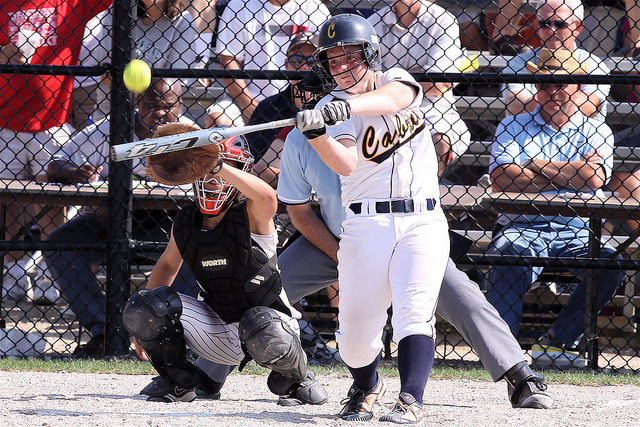How many people can you see in the image? In the image, there are three people in focus: the batter swinging the bat, the catcher crouched behind the batter ready to catch the ball, and the umpire standing behind the catcher monitoring the game. 